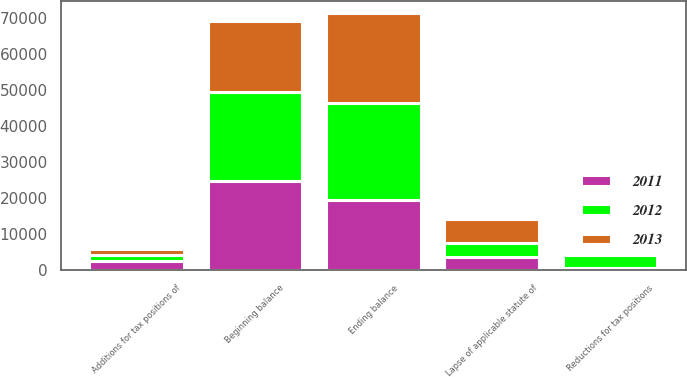Convert chart. <chart><loc_0><loc_0><loc_500><loc_500><stacked_bar_chart><ecel><fcel>Beginning balance<fcel>Additions for tax positions of<fcel>Reductions for tax positions<fcel>Lapse of applicable statute of<fcel>Ending balance<nl><fcel>2012<fcel>24865<fcel>1639<fcel>3675<fcel>3986<fcel>26924<nl><fcel>2013<fcel>19556<fcel>1541<fcel>197<fcel>6522<fcel>24865<nl><fcel>2011<fcel>24765<fcel>2572<fcel>558<fcel>3650<fcel>19556<nl></chart> 